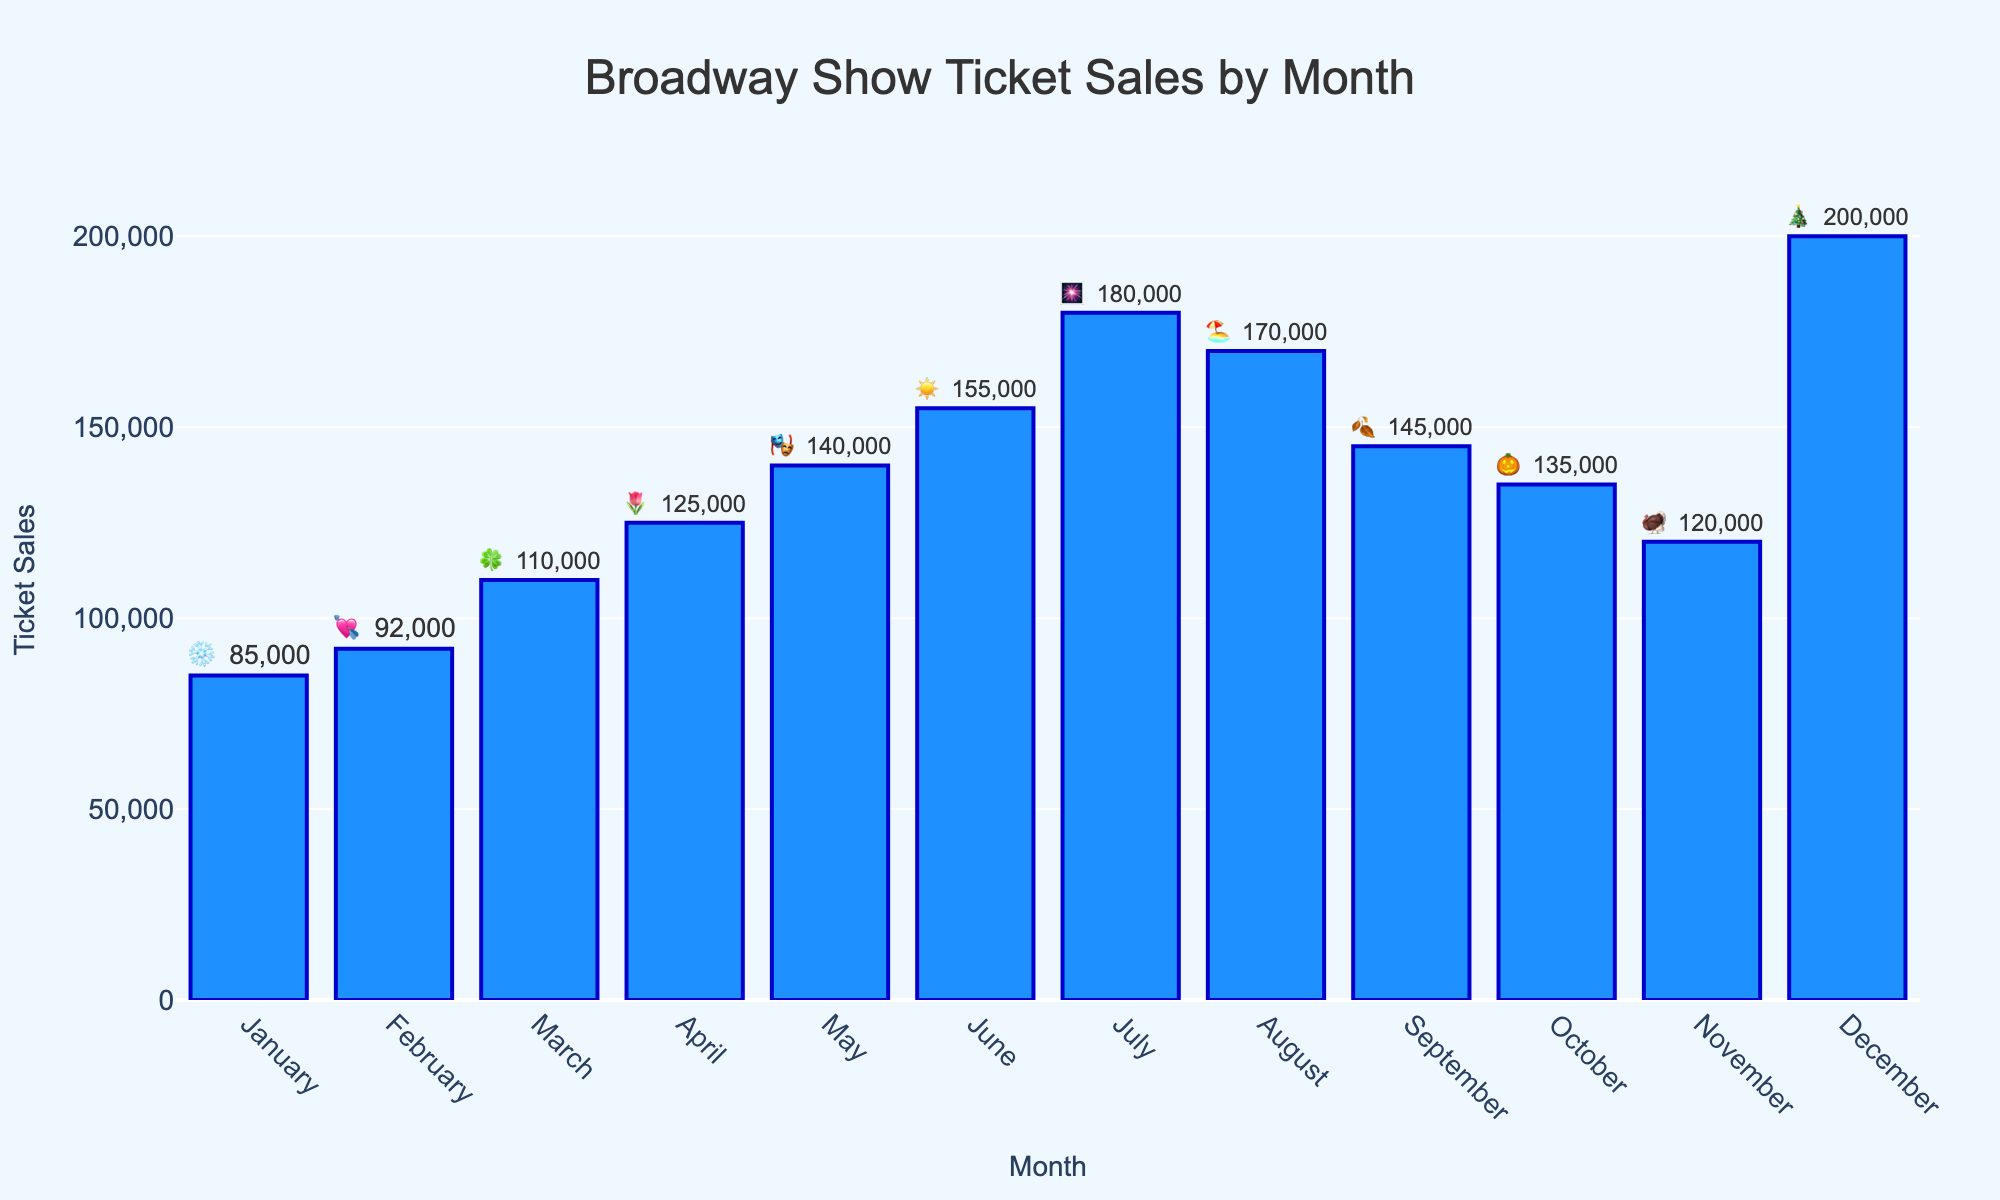What's the title of the chart? The title is usually displayed at the top of the chart. Here it reads "Broadway Show Ticket Sales by Month."
Answer: Broadway Show Ticket Sales by Month Which month has the highest ticket sales? By looking at the heights of the bars plotted for each month, December stands out as having the tallest bar, indicating the highest ticket sales.
Answer: December What's the sum of ticket sales for the first and last month? According to the data, January has 85,000 tickets and December has 200,000 tickets. Adding these together gives 300,000 tickets.
Answer: 285,000 tickets Which month's ticket sales exceed 150,000? Observing the bars, both June (155,000) and July (180,000) have ticket sales that exceed 150,000.
Answer: June and July What is the emoji for November, and what does it represent? Each month has a corresponding holiday-themed emoji. In November, it is 🦃 which represents Thanksgiving.
Answer: 🦃 (Thanksgiving) How much higher are ticket sales in July compared to March? July has 180,000 tickets and March has 110,000. Subtracting these gives the difference: 180,000 - 110,000 = 70,000 tickets.
Answer: 70,000 tickets Which month shows an increase in ticket sales compared to the previous month? Comparing month-to-month, many increases are visible. For instance, April increases from March, May increases from April, June from May, and July from June.
Answer: April, May, June, and July How many months have ticket sales below 100,000? By looking at the bars, only January and February have ticket sales below 100,000.
Answer: 2 months What's the average ticket sales from January to June? Adding ticket sales from January (85,000), February (92,000), March (110,000), April (125,000), May (140,000), and June (155,000) gives a total of 707,000. Dividing by 6 months gives an average of 707,000 / 6 ≈ 117,833.33 tickets.
Answer: Approximately 117,833 tickets 